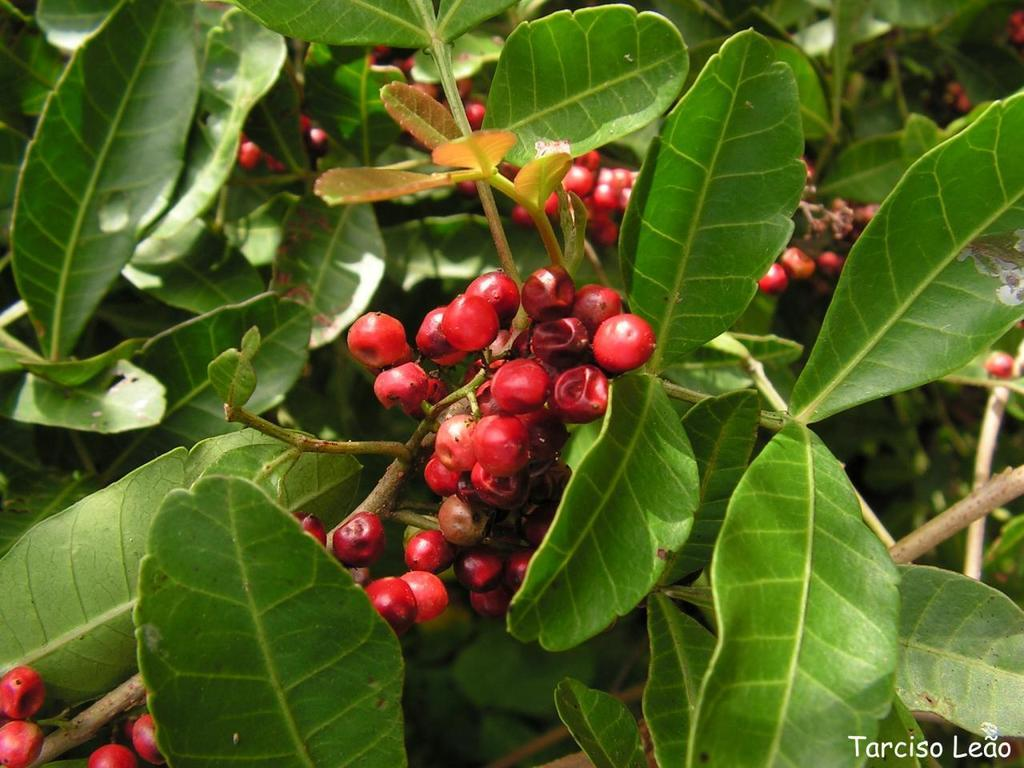What type of plants are visible in the image? The plants in the image have fruits on them. What can be found on the plants in the image? Fruits are on the plants in the image. How many sails are visible on the queen in the image? There is no queen or sail present in the image; it features plants with fruits. 